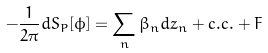Convert formula to latex. <formula><loc_0><loc_0><loc_500><loc_500>- \frac { 1 } { 2 \pi } d S _ { P } [ \phi ] = \sum _ { n } \beta _ { n } d z _ { n } + c . c . + F</formula> 